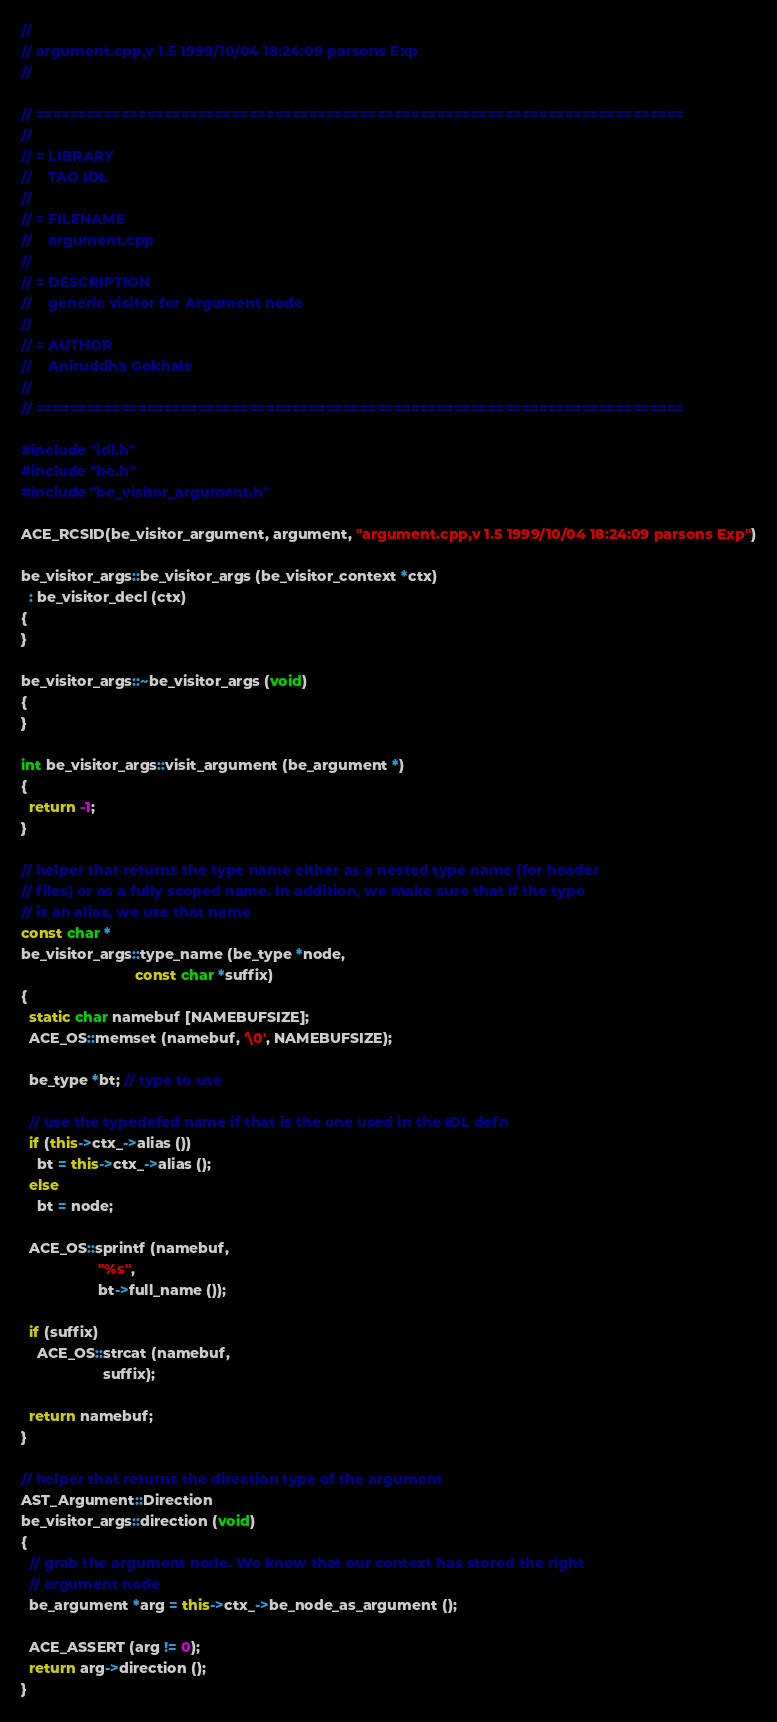<code> <loc_0><loc_0><loc_500><loc_500><_C++_>//
// argument.cpp,v 1.5 1999/10/04 18:24:09 parsons Exp
//

// ============================================================================
//
// = LIBRARY
//    TAO IDL
//
// = FILENAME
//    argument.cpp
//
// = DESCRIPTION
//    generic visitor for Argument node
//
// = AUTHOR
//    Aniruddha Gokhale
//
// ============================================================================

#include "idl.h"
#include "be.h"
#include "be_visitor_argument.h"

ACE_RCSID(be_visitor_argument, argument, "argument.cpp,v 1.5 1999/10/04 18:24:09 parsons Exp")

be_visitor_args::be_visitor_args (be_visitor_context *ctx)
  : be_visitor_decl (ctx)
{
}

be_visitor_args::~be_visitor_args (void)
{
}

int be_visitor_args::visit_argument (be_argument *)
{
  return -1;
}

// helper that returns the type name either as a nested type name (for header
// files) or as a fully scoped name. In addition, we make sure that if the type
// is an alias, we use that name
const char *
be_visitor_args::type_name (be_type *node, 
                            const char *suffix)
{
  static char namebuf [NAMEBUFSIZE];
  ACE_OS::memset (namebuf, '\0', NAMEBUFSIZE);

  be_type *bt; // type to use

  // use the typedefed name if that is the one used in the IDL defn
  if (this->ctx_->alias ())
    bt = this->ctx_->alias ();
  else
    bt = node;

  ACE_OS::sprintf (namebuf, 
                   "%s", 
                   bt->full_name ());

  if (suffix)
    ACE_OS::strcat (namebuf, 
                    suffix);

  return namebuf;
}

// helper that returns the direction type of the argument
AST_Argument::Direction
be_visitor_args::direction (void)
{
  // grab the argument node. We know that our context has stored the right
  // argument node
  be_argument *arg = this->ctx_->be_node_as_argument ();

  ACE_ASSERT (arg != 0);
  return arg->direction ();
}
</code> 